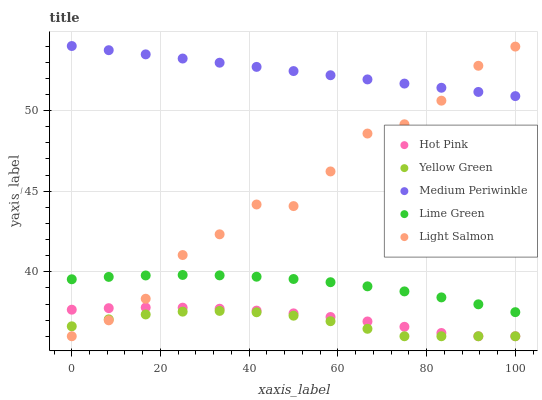Does Yellow Green have the minimum area under the curve?
Answer yes or no. Yes. Does Medium Periwinkle have the maximum area under the curve?
Answer yes or no. Yes. Does Light Salmon have the minimum area under the curve?
Answer yes or no. No. Does Light Salmon have the maximum area under the curve?
Answer yes or no. No. Is Medium Periwinkle the smoothest?
Answer yes or no. Yes. Is Light Salmon the roughest?
Answer yes or no. Yes. Is Hot Pink the smoothest?
Answer yes or no. No. Is Hot Pink the roughest?
Answer yes or no. No. Does Light Salmon have the lowest value?
Answer yes or no. Yes. Does Medium Periwinkle have the lowest value?
Answer yes or no. No. Does Medium Periwinkle have the highest value?
Answer yes or no. Yes. Does Light Salmon have the highest value?
Answer yes or no. No. Is Hot Pink less than Medium Periwinkle?
Answer yes or no. Yes. Is Medium Periwinkle greater than Yellow Green?
Answer yes or no. Yes. Does Hot Pink intersect Light Salmon?
Answer yes or no. Yes. Is Hot Pink less than Light Salmon?
Answer yes or no. No. Is Hot Pink greater than Light Salmon?
Answer yes or no. No. Does Hot Pink intersect Medium Periwinkle?
Answer yes or no. No. 